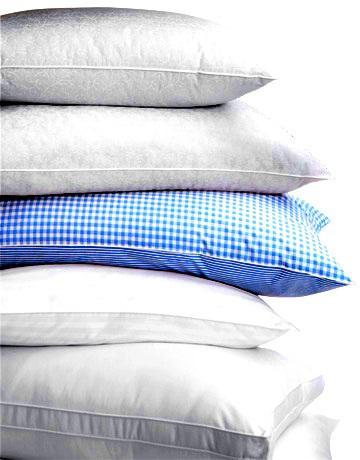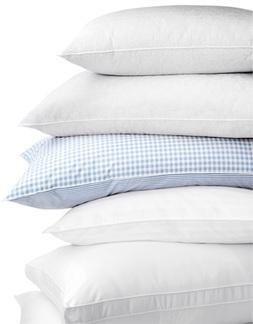The first image is the image on the left, the second image is the image on the right. For the images shown, is this caption "There are two stacks of four pillows." true? Answer yes or no. No. The first image is the image on the left, the second image is the image on the right. Given the left and right images, does the statement "The left image contains a vertical stack of exactly four pillows." hold true? Answer yes or no. No. 